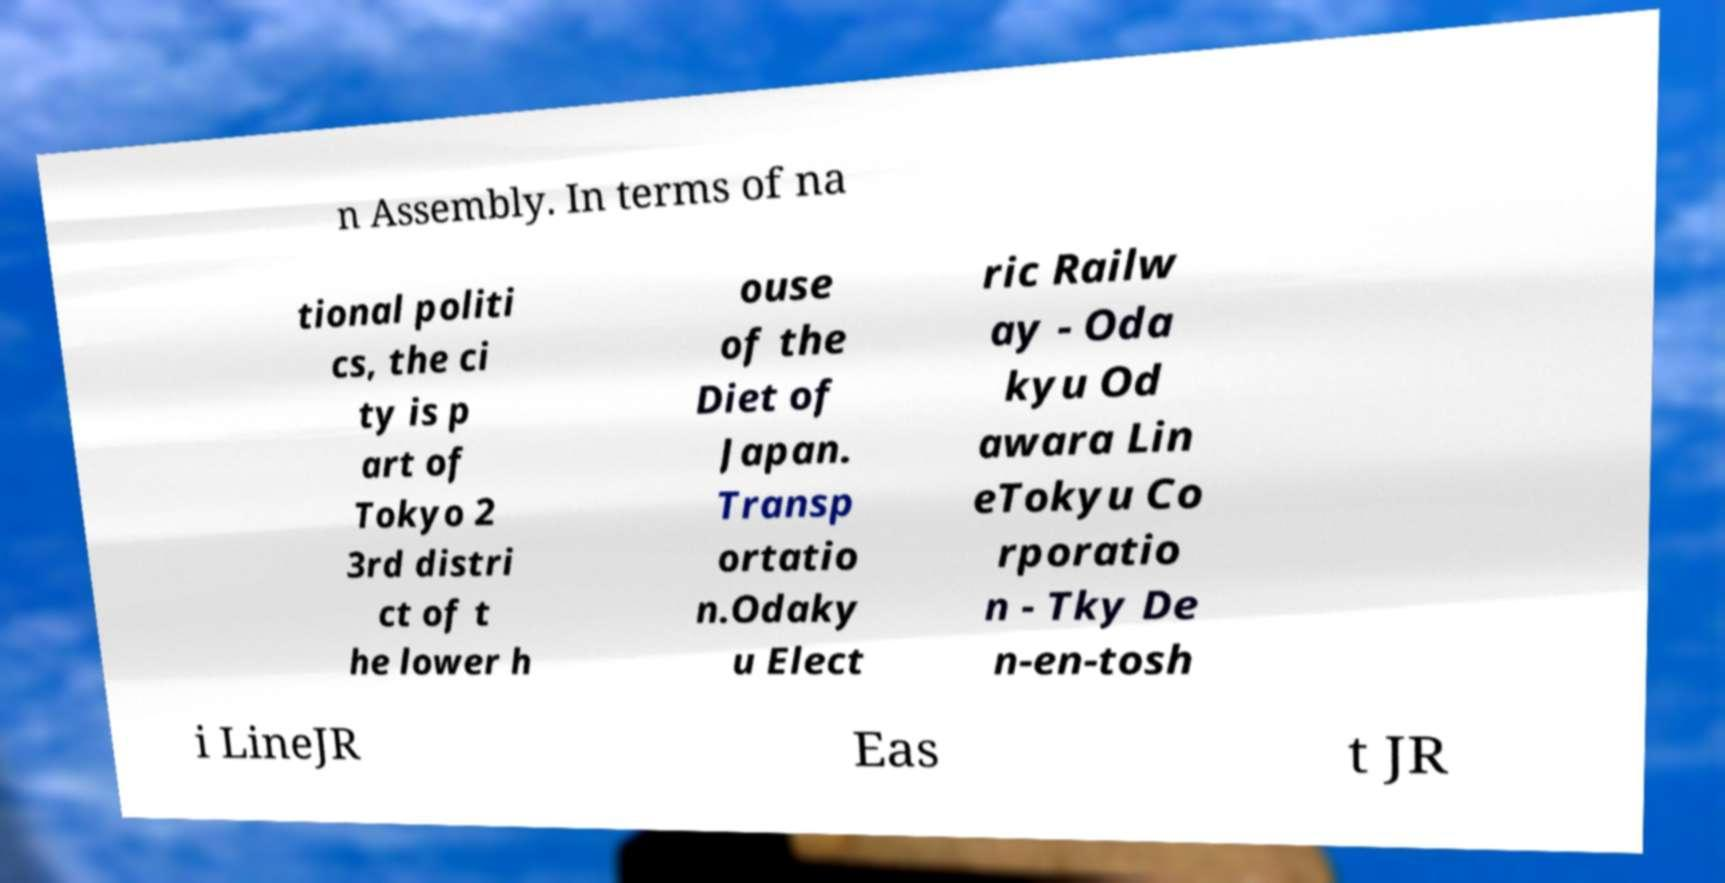Please identify and transcribe the text found in this image. n Assembly. In terms of na tional politi cs, the ci ty is p art of Tokyo 2 3rd distri ct of t he lower h ouse of the Diet of Japan. Transp ortatio n.Odaky u Elect ric Railw ay - Oda kyu Od awara Lin eTokyu Co rporatio n - Tky De n-en-tosh i LineJR Eas t JR 